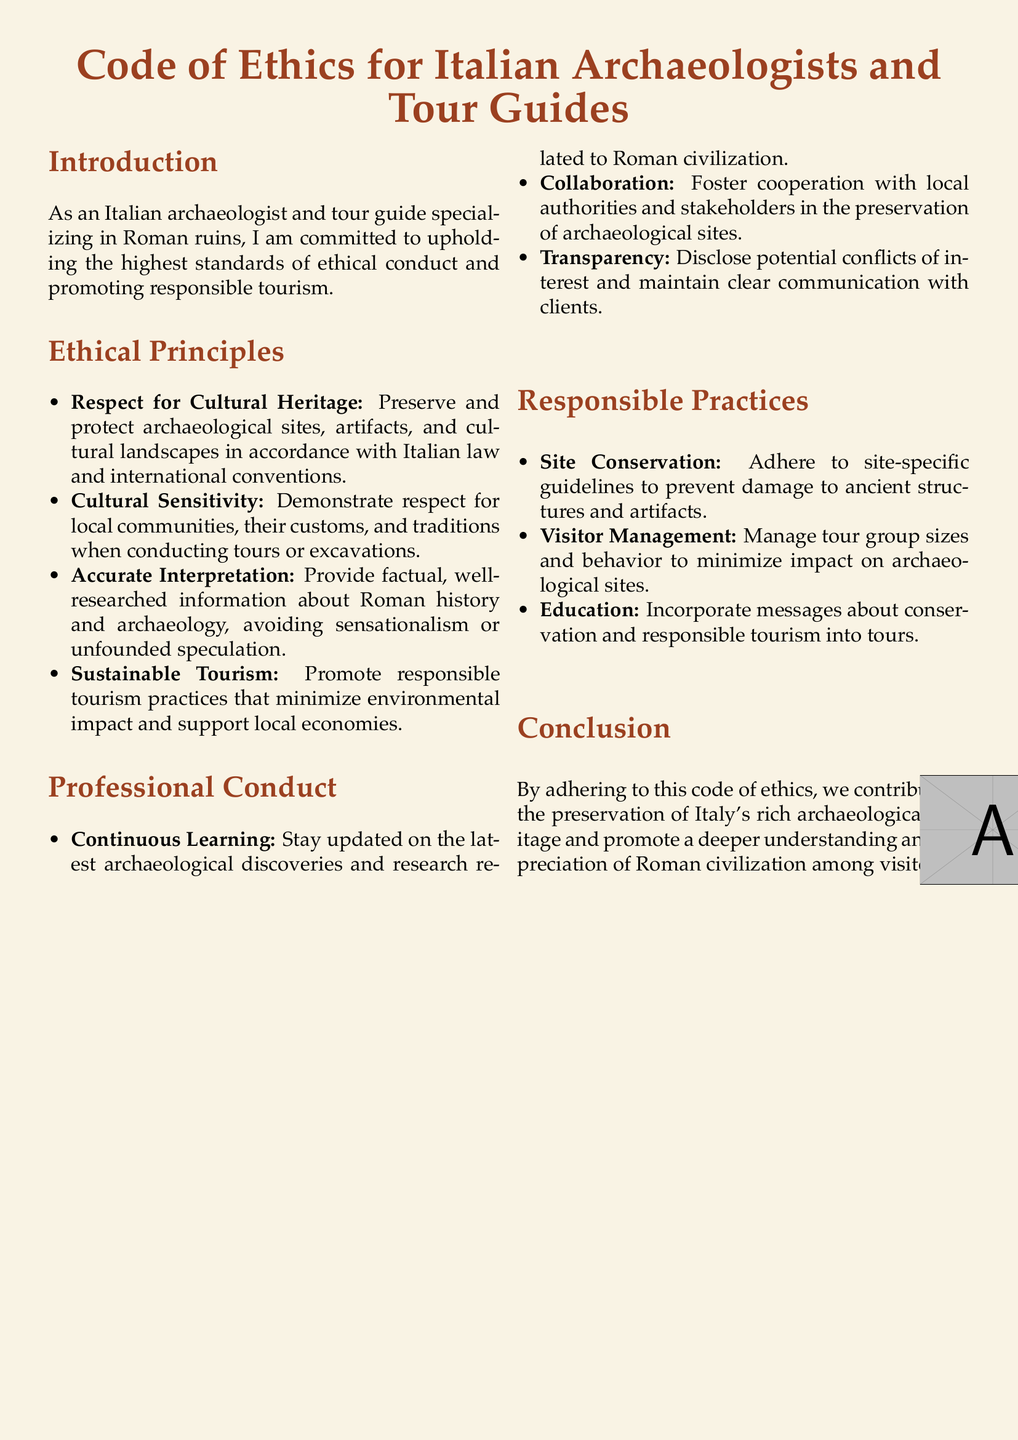What are the ethical principles highlighted in the document? The document lists multiple ethical principles that guide the behavior of archaeologists and tour guides.
Answer: Respect for Cultural Heritage, Cultural Sensitivity, Accurate Interpretation, Sustainable Tourism What is the main focus of the introduction? The introduction emphasizes the commitment to ethical standards and responsible tourism in the context of Roman ruins.
Answer: Upholding the highest standards of ethical conduct and promoting responsible tourism How many sections are in the document? The main body of the document is structured into several key sections that outline different topics.
Answer: Five What is one responsible practice mentioned in the document? The document outlines specific practices that promote responsible behavior in tourism and archaeology settings.
Answer: Site Conservation What does the code emphasize regarding local communities? The document stresses the importance of respect for the customs and traditions of local communities.
Answer: Cultural Sensitivity Which principle involves providing accurate historical information? The ethical principle that ensures information shared during tours is factual and researched.
Answer: Accurate Interpretation What type of tourism does the document promote? The code encourages practices that reduce environmental impact and support local economies.
Answer: Sustainable Tourism What does "Continuous Learning" refer to in professional conduct? This principle addresses the importance of staying updated with archaeological discoveries and research.
Answer: Stay updated on the latest archaeological discoveries How should tour group sizes be managed? The document provides guidance on managing tour groups to minimize their impact on archaeological sites.
Answer: Manage tour group sizes and behavior What is the conclusion's message about the code of ethics? The conclusion highlights the overall purpose of adhering to these ethical guidelines in relation to heritage preservation.
Answer: Contribute to the preservation of Italy's rich archaeological heritage 